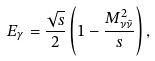Convert formula to latex. <formula><loc_0><loc_0><loc_500><loc_500>E _ { \gamma } = \frac { \sqrt { s } } { 2 } \left ( 1 - \frac { M _ { \nu \bar { \nu } } ^ { 2 } } { s } \right ) ,</formula> 